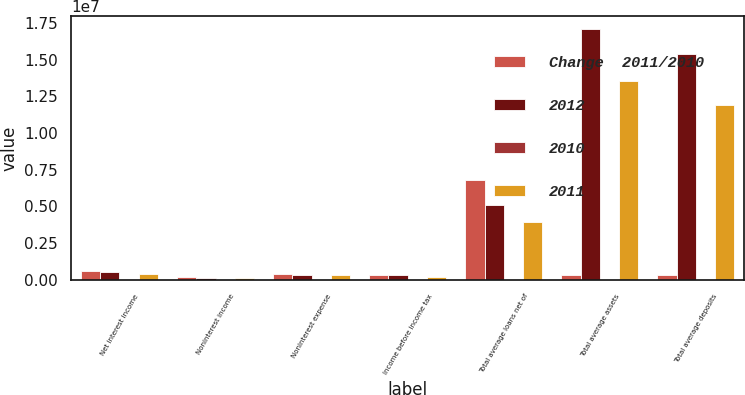<chart> <loc_0><loc_0><loc_500><loc_500><stacked_bar_chart><ecel><fcel>Net interest income<fcel>Noninterest income<fcel>Noninterest expense<fcel>Income before income tax<fcel>Total average loans net of<fcel>Total average assets<fcel>Total average deposits<nl><fcel>Change  2011/2010<fcel>595133<fcel>188842<fcel>397672<fcel>340886<fcel>6.79033e+06<fcel>323170<fcel>323170<nl><fcel>2012<fcel>519145<fcel>150116<fcel>355705<fcel>300062<fcel>5.09952e+06<fcel>1.71042e+07<fcel>1.53648e+07<nl><fcel>2010<fcel>14.6<fcel>25.8<fcel>11.8<fcel>13.6<fcel>33.2<fcel>14.1<fcel>14.4<nl><fcel>2011<fcel>424256<fcel>136531<fcel>305454<fcel>212976<fcel>3.94887e+06<fcel>1.35581e+07<fcel>1.19116e+07<nl></chart> 